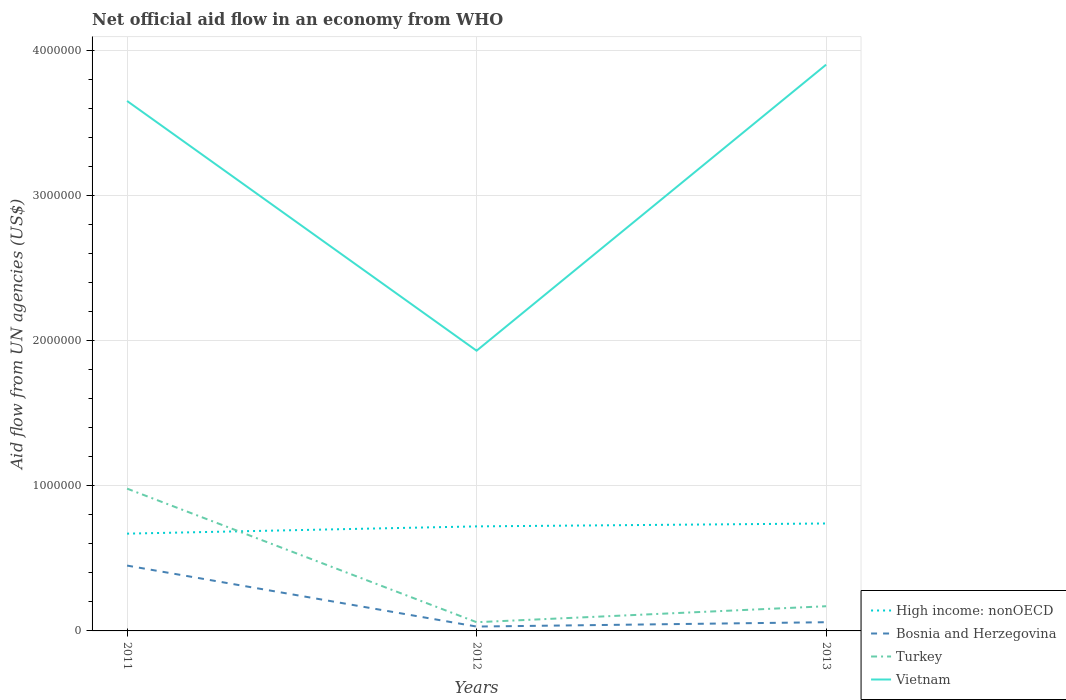How many different coloured lines are there?
Offer a terse response. 4. Is the number of lines equal to the number of legend labels?
Your answer should be compact. Yes. Across all years, what is the maximum net official aid flow in High income: nonOECD?
Your response must be concise. 6.70e+05. In which year was the net official aid flow in High income: nonOECD maximum?
Your answer should be compact. 2011. What is the difference between the highest and the second highest net official aid flow in Turkey?
Make the answer very short. 9.20e+05. What is the difference between the highest and the lowest net official aid flow in Turkey?
Give a very brief answer. 1. Where does the legend appear in the graph?
Your response must be concise. Bottom right. How many legend labels are there?
Provide a short and direct response. 4. What is the title of the graph?
Give a very brief answer. Net official aid flow in an economy from WHO. What is the label or title of the Y-axis?
Offer a terse response. Aid flow from UN agencies (US$). What is the Aid flow from UN agencies (US$) of High income: nonOECD in 2011?
Ensure brevity in your answer.  6.70e+05. What is the Aid flow from UN agencies (US$) in Bosnia and Herzegovina in 2011?
Make the answer very short. 4.50e+05. What is the Aid flow from UN agencies (US$) in Turkey in 2011?
Provide a short and direct response. 9.80e+05. What is the Aid flow from UN agencies (US$) of Vietnam in 2011?
Offer a very short reply. 3.65e+06. What is the Aid flow from UN agencies (US$) of High income: nonOECD in 2012?
Your answer should be very brief. 7.20e+05. What is the Aid flow from UN agencies (US$) of Vietnam in 2012?
Offer a very short reply. 1.93e+06. What is the Aid flow from UN agencies (US$) in High income: nonOECD in 2013?
Your response must be concise. 7.40e+05. What is the Aid flow from UN agencies (US$) of Bosnia and Herzegovina in 2013?
Provide a short and direct response. 6.00e+04. What is the Aid flow from UN agencies (US$) of Vietnam in 2013?
Your answer should be very brief. 3.90e+06. Across all years, what is the maximum Aid flow from UN agencies (US$) of High income: nonOECD?
Make the answer very short. 7.40e+05. Across all years, what is the maximum Aid flow from UN agencies (US$) of Turkey?
Your answer should be very brief. 9.80e+05. Across all years, what is the maximum Aid flow from UN agencies (US$) in Vietnam?
Offer a very short reply. 3.90e+06. Across all years, what is the minimum Aid flow from UN agencies (US$) of High income: nonOECD?
Ensure brevity in your answer.  6.70e+05. Across all years, what is the minimum Aid flow from UN agencies (US$) of Vietnam?
Ensure brevity in your answer.  1.93e+06. What is the total Aid flow from UN agencies (US$) in High income: nonOECD in the graph?
Offer a very short reply. 2.13e+06. What is the total Aid flow from UN agencies (US$) in Bosnia and Herzegovina in the graph?
Your response must be concise. 5.40e+05. What is the total Aid flow from UN agencies (US$) in Turkey in the graph?
Offer a very short reply. 1.21e+06. What is the total Aid flow from UN agencies (US$) in Vietnam in the graph?
Ensure brevity in your answer.  9.48e+06. What is the difference between the Aid flow from UN agencies (US$) in Turkey in 2011 and that in 2012?
Provide a short and direct response. 9.20e+05. What is the difference between the Aid flow from UN agencies (US$) of Vietnam in 2011 and that in 2012?
Your answer should be very brief. 1.72e+06. What is the difference between the Aid flow from UN agencies (US$) in Bosnia and Herzegovina in 2011 and that in 2013?
Give a very brief answer. 3.90e+05. What is the difference between the Aid flow from UN agencies (US$) of Turkey in 2011 and that in 2013?
Offer a terse response. 8.10e+05. What is the difference between the Aid flow from UN agencies (US$) of Vietnam in 2011 and that in 2013?
Ensure brevity in your answer.  -2.50e+05. What is the difference between the Aid flow from UN agencies (US$) of High income: nonOECD in 2012 and that in 2013?
Make the answer very short. -2.00e+04. What is the difference between the Aid flow from UN agencies (US$) in Vietnam in 2012 and that in 2013?
Offer a terse response. -1.97e+06. What is the difference between the Aid flow from UN agencies (US$) of High income: nonOECD in 2011 and the Aid flow from UN agencies (US$) of Bosnia and Herzegovina in 2012?
Your answer should be compact. 6.40e+05. What is the difference between the Aid flow from UN agencies (US$) of High income: nonOECD in 2011 and the Aid flow from UN agencies (US$) of Vietnam in 2012?
Offer a terse response. -1.26e+06. What is the difference between the Aid flow from UN agencies (US$) of Bosnia and Herzegovina in 2011 and the Aid flow from UN agencies (US$) of Turkey in 2012?
Your answer should be very brief. 3.90e+05. What is the difference between the Aid flow from UN agencies (US$) of Bosnia and Herzegovina in 2011 and the Aid flow from UN agencies (US$) of Vietnam in 2012?
Give a very brief answer. -1.48e+06. What is the difference between the Aid flow from UN agencies (US$) in Turkey in 2011 and the Aid flow from UN agencies (US$) in Vietnam in 2012?
Your response must be concise. -9.50e+05. What is the difference between the Aid flow from UN agencies (US$) of High income: nonOECD in 2011 and the Aid flow from UN agencies (US$) of Turkey in 2013?
Offer a terse response. 5.00e+05. What is the difference between the Aid flow from UN agencies (US$) of High income: nonOECD in 2011 and the Aid flow from UN agencies (US$) of Vietnam in 2013?
Give a very brief answer. -3.23e+06. What is the difference between the Aid flow from UN agencies (US$) in Bosnia and Herzegovina in 2011 and the Aid flow from UN agencies (US$) in Turkey in 2013?
Offer a very short reply. 2.80e+05. What is the difference between the Aid flow from UN agencies (US$) in Bosnia and Herzegovina in 2011 and the Aid flow from UN agencies (US$) in Vietnam in 2013?
Your answer should be compact. -3.45e+06. What is the difference between the Aid flow from UN agencies (US$) in Turkey in 2011 and the Aid flow from UN agencies (US$) in Vietnam in 2013?
Provide a succinct answer. -2.92e+06. What is the difference between the Aid flow from UN agencies (US$) of High income: nonOECD in 2012 and the Aid flow from UN agencies (US$) of Bosnia and Herzegovina in 2013?
Make the answer very short. 6.60e+05. What is the difference between the Aid flow from UN agencies (US$) of High income: nonOECD in 2012 and the Aid flow from UN agencies (US$) of Vietnam in 2013?
Your answer should be compact. -3.18e+06. What is the difference between the Aid flow from UN agencies (US$) in Bosnia and Herzegovina in 2012 and the Aid flow from UN agencies (US$) in Vietnam in 2013?
Ensure brevity in your answer.  -3.87e+06. What is the difference between the Aid flow from UN agencies (US$) of Turkey in 2012 and the Aid flow from UN agencies (US$) of Vietnam in 2013?
Provide a succinct answer. -3.84e+06. What is the average Aid flow from UN agencies (US$) of High income: nonOECD per year?
Make the answer very short. 7.10e+05. What is the average Aid flow from UN agencies (US$) in Bosnia and Herzegovina per year?
Make the answer very short. 1.80e+05. What is the average Aid flow from UN agencies (US$) in Turkey per year?
Offer a terse response. 4.03e+05. What is the average Aid flow from UN agencies (US$) in Vietnam per year?
Offer a very short reply. 3.16e+06. In the year 2011, what is the difference between the Aid flow from UN agencies (US$) in High income: nonOECD and Aid flow from UN agencies (US$) in Turkey?
Provide a succinct answer. -3.10e+05. In the year 2011, what is the difference between the Aid flow from UN agencies (US$) in High income: nonOECD and Aid flow from UN agencies (US$) in Vietnam?
Provide a succinct answer. -2.98e+06. In the year 2011, what is the difference between the Aid flow from UN agencies (US$) in Bosnia and Herzegovina and Aid flow from UN agencies (US$) in Turkey?
Give a very brief answer. -5.30e+05. In the year 2011, what is the difference between the Aid flow from UN agencies (US$) of Bosnia and Herzegovina and Aid flow from UN agencies (US$) of Vietnam?
Your answer should be compact. -3.20e+06. In the year 2011, what is the difference between the Aid flow from UN agencies (US$) of Turkey and Aid flow from UN agencies (US$) of Vietnam?
Make the answer very short. -2.67e+06. In the year 2012, what is the difference between the Aid flow from UN agencies (US$) in High income: nonOECD and Aid flow from UN agencies (US$) in Bosnia and Herzegovina?
Ensure brevity in your answer.  6.90e+05. In the year 2012, what is the difference between the Aid flow from UN agencies (US$) in High income: nonOECD and Aid flow from UN agencies (US$) in Vietnam?
Offer a very short reply. -1.21e+06. In the year 2012, what is the difference between the Aid flow from UN agencies (US$) of Bosnia and Herzegovina and Aid flow from UN agencies (US$) of Vietnam?
Give a very brief answer. -1.90e+06. In the year 2012, what is the difference between the Aid flow from UN agencies (US$) in Turkey and Aid flow from UN agencies (US$) in Vietnam?
Your answer should be compact. -1.87e+06. In the year 2013, what is the difference between the Aid flow from UN agencies (US$) of High income: nonOECD and Aid flow from UN agencies (US$) of Bosnia and Herzegovina?
Provide a succinct answer. 6.80e+05. In the year 2013, what is the difference between the Aid flow from UN agencies (US$) of High income: nonOECD and Aid flow from UN agencies (US$) of Turkey?
Give a very brief answer. 5.70e+05. In the year 2013, what is the difference between the Aid flow from UN agencies (US$) in High income: nonOECD and Aid flow from UN agencies (US$) in Vietnam?
Keep it short and to the point. -3.16e+06. In the year 2013, what is the difference between the Aid flow from UN agencies (US$) of Bosnia and Herzegovina and Aid flow from UN agencies (US$) of Vietnam?
Keep it short and to the point. -3.84e+06. In the year 2013, what is the difference between the Aid flow from UN agencies (US$) of Turkey and Aid flow from UN agencies (US$) of Vietnam?
Ensure brevity in your answer.  -3.73e+06. What is the ratio of the Aid flow from UN agencies (US$) in High income: nonOECD in 2011 to that in 2012?
Offer a terse response. 0.93. What is the ratio of the Aid flow from UN agencies (US$) in Turkey in 2011 to that in 2012?
Your answer should be very brief. 16.33. What is the ratio of the Aid flow from UN agencies (US$) of Vietnam in 2011 to that in 2012?
Your answer should be compact. 1.89. What is the ratio of the Aid flow from UN agencies (US$) of High income: nonOECD in 2011 to that in 2013?
Ensure brevity in your answer.  0.91. What is the ratio of the Aid flow from UN agencies (US$) of Turkey in 2011 to that in 2013?
Keep it short and to the point. 5.76. What is the ratio of the Aid flow from UN agencies (US$) in Vietnam in 2011 to that in 2013?
Your answer should be very brief. 0.94. What is the ratio of the Aid flow from UN agencies (US$) of Turkey in 2012 to that in 2013?
Offer a terse response. 0.35. What is the ratio of the Aid flow from UN agencies (US$) in Vietnam in 2012 to that in 2013?
Offer a very short reply. 0.49. What is the difference between the highest and the second highest Aid flow from UN agencies (US$) in High income: nonOECD?
Offer a very short reply. 2.00e+04. What is the difference between the highest and the second highest Aid flow from UN agencies (US$) in Turkey?
Keep it short and to the point. 8.10e+05. What is the difference between the highest and the second highest Aid flow from UN agencies (US$) in Vietnam?
Give a very brief answer. 2.50e+05. What is the difference between the highest and the lowest Aid flow from UN agencies (US$) in Bosnia and Herzegovina?
Your response must be concise. 4.20e+05. What is the difference between the highest and the lowest Aid flow from UN agencies (US$) in Turkey?
Give a very brief answer. 9.20e+05. What is the difference between the highest and the lowest Aid flow from UN agencies (US$) in Vietnam?
Offer a terse response. 1.97e+06. 